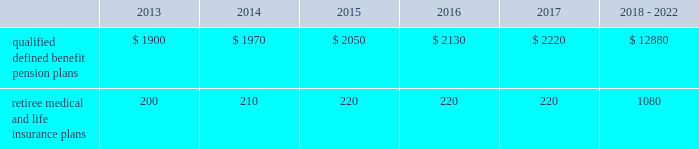Valuation techniques 2013 cash equivalents are mostly comprised of short-term money-market instruments and are valued at cost , which approximates fair value .
U.s .
Equity securities and international equity securities categorized as level 1 are traded on active national and international exchanges and are valued at their closing prices on the last trading day of the year .
For u.s .
Equity securities and international equity securities not traded on an active exchange , or if the closing price is not available , the trustee obtains indicative quotes from a pricing vendor , broker , or investment manager .
These securities are categorized as level 2 if the custodian obtains corroborated quotes from a pricing vendor or categorized as level 3 if the custodian obtains uncorroborated quotes from a broker or investment manager .
Commingled equity funds are public investment vehicles valued using the net asset value ( nav ) provided by the fund manager .
The nav is the total value of the fund divided by the number of shares outstanding .
Commingled equity funds are categorized as level 1 if traded at their nav on a nationally recognized securities exchange or categorized as level 2 if the nav is corroborated by observable market data ( e.g. , purchases or sales activity ) .
Fixed income securities categorized as level 2 are valued by the trustee using pricing models that use verifiable observable market data ( e.g .
Interest rates and yield curves observable at commonly quoted intervals ) , bids provided by brokers or dealers , or quoted prices of securities with similar characteristics .
Private equity funds , real estate funds , hedge funds , and fixed income securities categorized as level 3 are valued based on valuation models that include significant unobservable inputs and cannot be corroborated using verifiable observable market data .
Valuations for private equity funds and real estate funds are determined by the general partners , while hedge funds are valued by independent administrators .
Depending on the nature of the assets , the general partners or independent administrators use both the income and market approaches in their models .
The market approach consists of analyzing market transactions for comparable assets while the income approach uses earnings or the net present value of estimated future cash flows adjusted for liquidity and other risk factors .
Commodities categorized as level 1 are traded on an active commodity exchange and are valued at their closing prices on the last trading day of the year .
Commodities categorized as level 2 represent shares in a commingled commodity fund valued using the nav , which is corroborated by observable market data .
Contributions and expected benefit payments we generally determine funding requirements for our defined benefit pension plans in a manner consistent with cas and internal revenue code rules .
In 2012 , we made contributions of $ 3.6 billion related to our qualified defined benefit pension plans .
We plan to make contributions of approximately $ 1.5 billion related to the qualified defined benefit pension plans in 2013 .
In 2012 , we made contributions of $ 235 million related to our retiree medical and life insurance plans .
We expect no required contributions related to the retiree medical and life insurance plans in 2013 .
The table presents estimated future benefit payments , which reflect expected future employee service , as of december 31 , 2012 ( in millions ) : .
Defined contribution plans we maintain a number of defined contribution plans , most with 401 ( k ) features , that cover substantially all of our employees .
Under the provisions of our 401 ( k ) plans , we match most employees 2019 eligible contributions at rates specified in the plan documents .
Our contributions were $ 380 million in 2012 , $ 378 million in 2011 , and $ 379 million in 2010 , the majority of which were funded in our common stock .
Our defined contribution plans held approximately 48.6 million and 52.1 million shares of our common stock as of december 31 , 2012 and 2011. .
As of december 31 , 2012 what was the ratio of the estimated future benefit payments qualified defined benefit pension plans due in 2014 to the amount after 2018? 
Computations: (1970 / 12880)
Answer: 0.15295. 